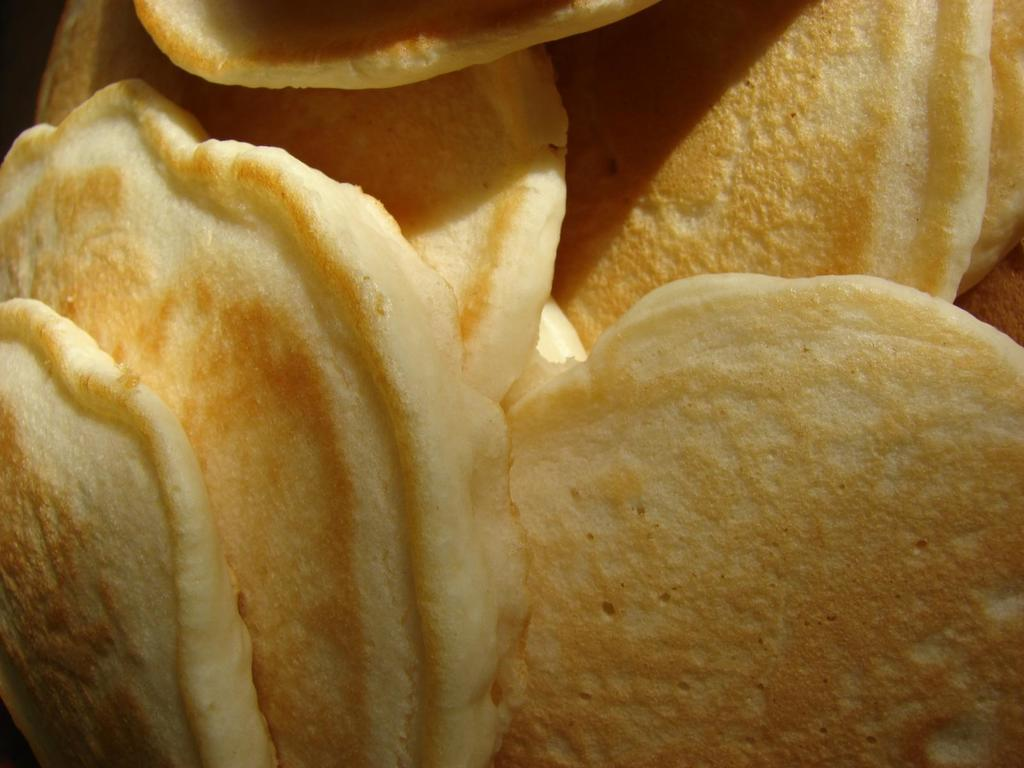What can be seen in the image? There is food visible in the image. What type of voice can be heard coming from the food in the image? There is no voice coming from the food in the image, as food does not have the ability to produce sound. 